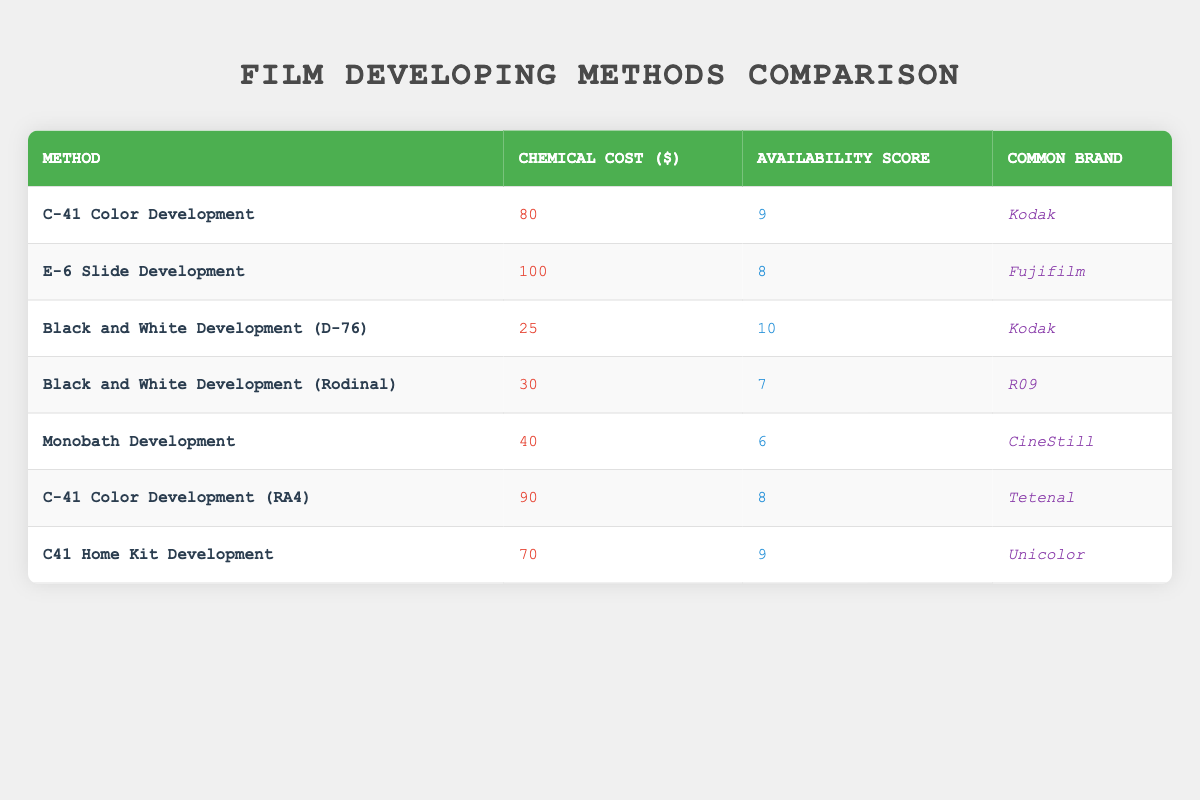What is the chemical cost of Black and White Development (D-76)? The chemical cost for Black and White Development (D-76) is given directly in the table as 25.
Answer: 25 Which film developing method has the highest availability score? Looking at the availability scores in each row, Black and White Development (D-76) has the highest score of 10.
Answer: Black and White Development (D-76) What is the chemical cost difference between E-6 Slide Development and C-41 Color Development? The chemical cost for E-6 Slide Development is 100, and for C-41 Color Development, it is 80. Therefore, the difference is 100 - 80 = 20.
Answer: 20 Is the common brand for Monobath Development CineStill? The table lists CineStill as the common brand for Monobath Development, confirming the statement as true.
Answer: Yes What is the average chemical cost of all the film developing methods listed in the table? To find the average, sum up all the chemical costs: (80 + 100 + 25 + 30 + 40 + 90 + 70) = 435. There are 7 methods, so the average is 435 / 7 ≈ 62.14.
Answer: 62.14 Which method has a lower availability score than 7, and what is its chemical cost? The method that has an availability score lower than 7 is Monobath Development with a score of 6 and a chemical cost of 40.
Answer: Monobath Development, 40 What movie developing method is the most expensive, and how much does it cost? From the table, E-6 Slide Development has the highest chemical cost of 100, making it the most expensive method.
Answer: E-6 Slide Development, 100 How many methods have a chemical cost below 50? The methods with chemical costs below 50 are Black and White Development (D-76) at 25, Black and White Development (Rodinal) at 30, and Monobath Development at 40. In total, that is three methods.
Answer: 3 Does C-41 Color Development (RA4) have a higher chemical cost than C41 Home Kit Development? The chemical cost for C-41 Color Development (RA4) is 90, which is higher than the cost of C41 Home Kit Development, which is 70. Therefore, the statement is true.
Answer: Yes 